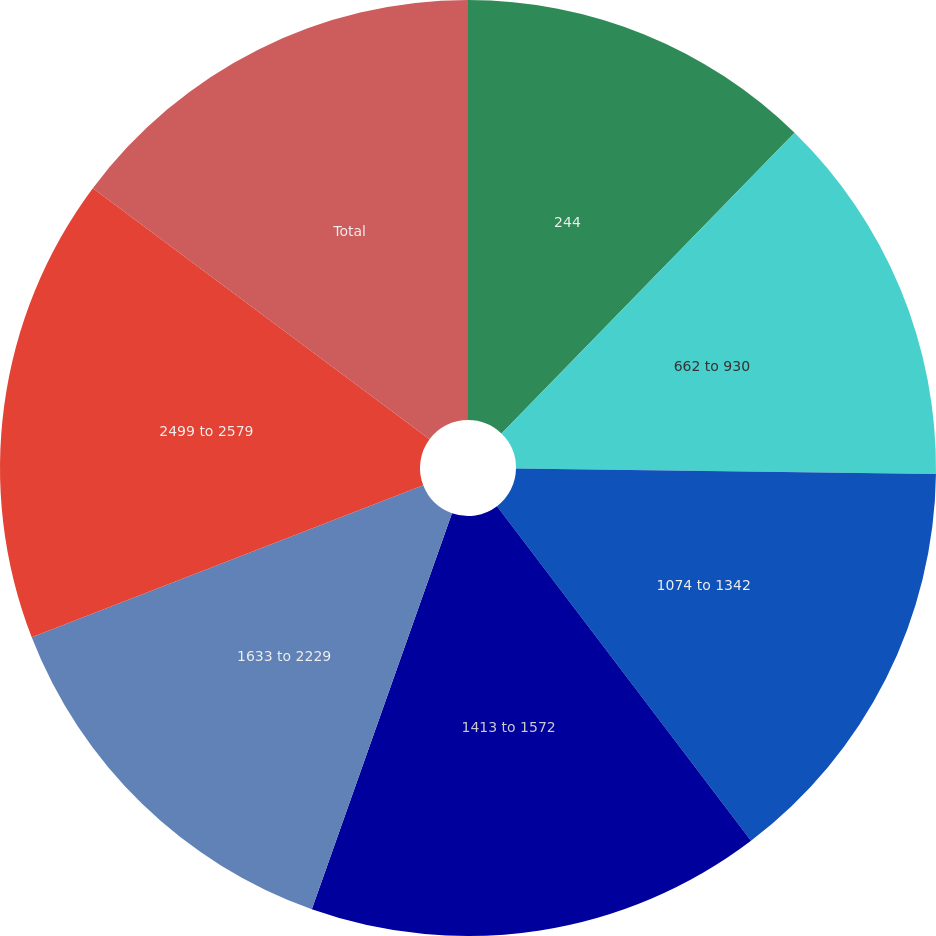Convert chart. <chart><loc_0><loc_0><loc_500><loc_500><pie_chart><fcel>244<fcel>662 to 930<fcel>1074 to 1342<fcel>1413 to 1572<fcel>1633 to 2229<fcel>2499 to 2579<fcel>Total<nl><fcel>12.29%<fcel>12.91%<fcel>14.46%<fcel>15.75%<fcel>13.69%<fcel>16.09%<fcel>14.8%<nl></chart> 